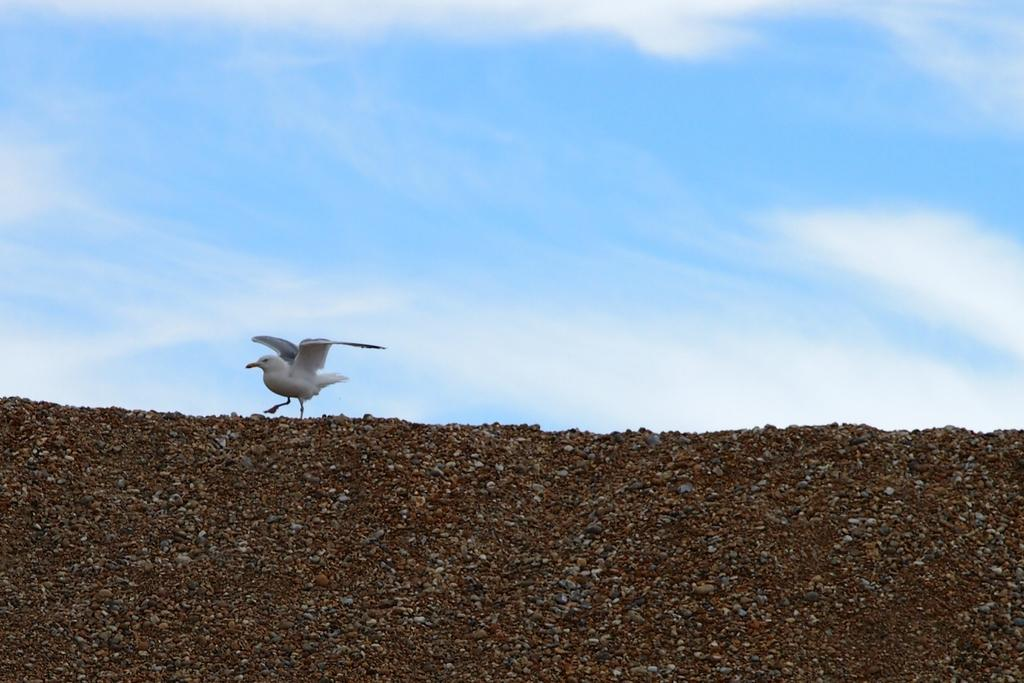What type of animal can be seen in the image? There is a bird in the image. Where is the bird located? The bird is on the land. What can be found on the land in the image? The land has rocks. What is visible at the top of the image? The sky is visible at the top of the image. What can be seen in the sky? There are clouds in the sky. What type of minister, or dad can be seen in the image? There is no minister, fiction, or dad present in the image; it features a bird on the land with rocks and a sky with clouds. 